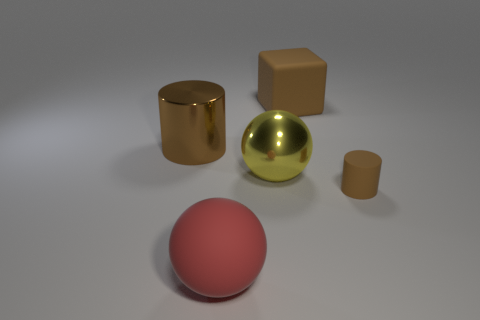Are there any other things that are the same size as the brown rubber cylinder?
Provide a succinct answer. No. What is the large red ball made of?
Your response must be concise. Rubber. What number of other things are there of the same color as the cube?
Make the answer very short. 2. There is a tiny rubber object; is its shape the same as the metallic thing that is left of the large metallic ball?
Provide a short and direct response. Yes. Are there fewer large yellow shiny things that are in front of the matte block than matte things that are in front of the big yellow sphere?
Offer a very short reply. Yes. There is another brown thing that is the same shape as the large brown metal object; what is its material?
Your answer should be compact. Rubber. Do the tiny cylinder and the large rubber ball have the same color?
Make the answer very short. No. What shape is the large thing that is made of the same material as the red sphere?
Give a very brief answer. Cube. How many large brown objects are the same shape as the red thing?
Your response must be concise. 0. What shape is the brown thing behind the metallic object that is on the left side of the big red rubber thing?
Make the answer very short. Cube. 